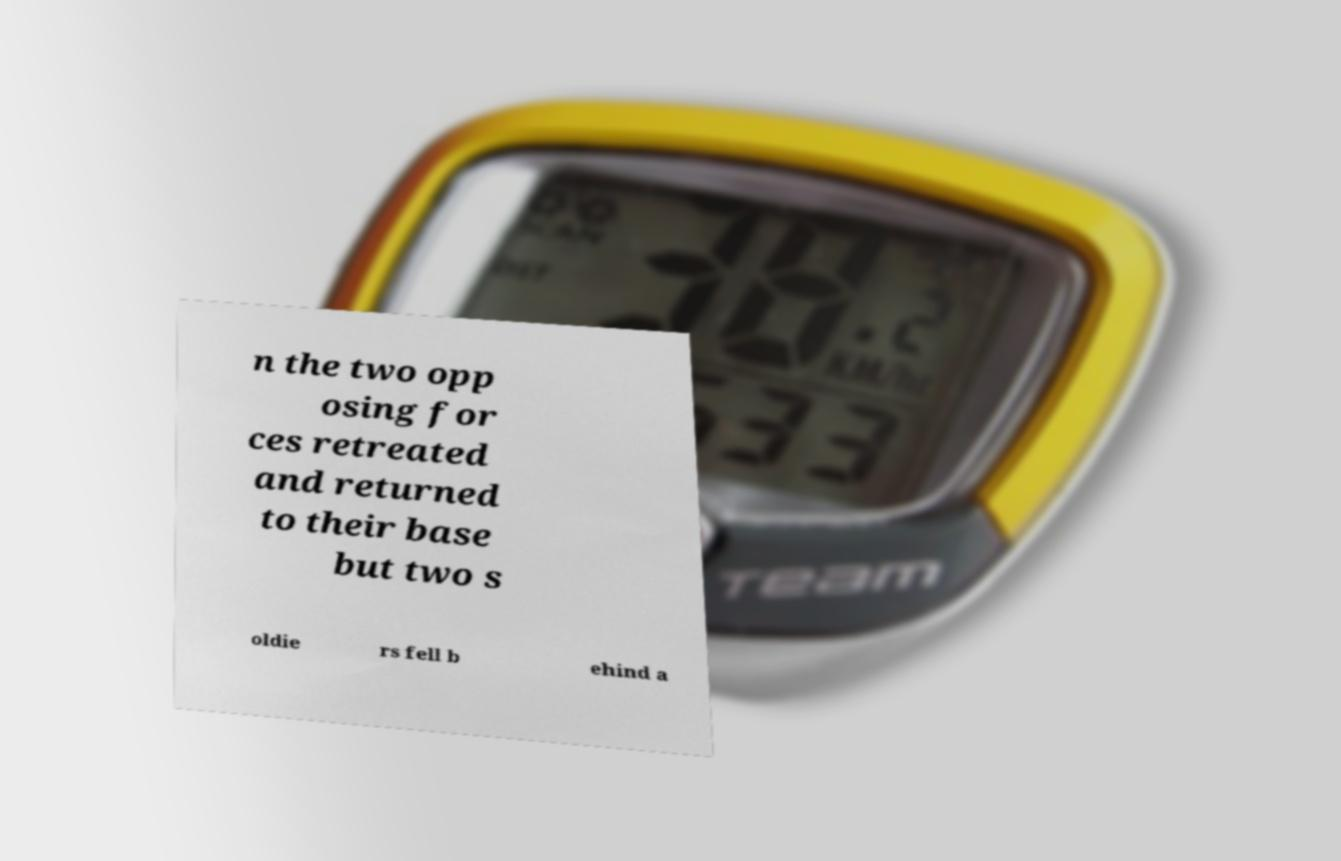For documentation purposes, I need the text within this image transcribed. Could you provide that? n the two opp osing for ces retreated and returned to their base but two s oldie rs fell b ehind a 